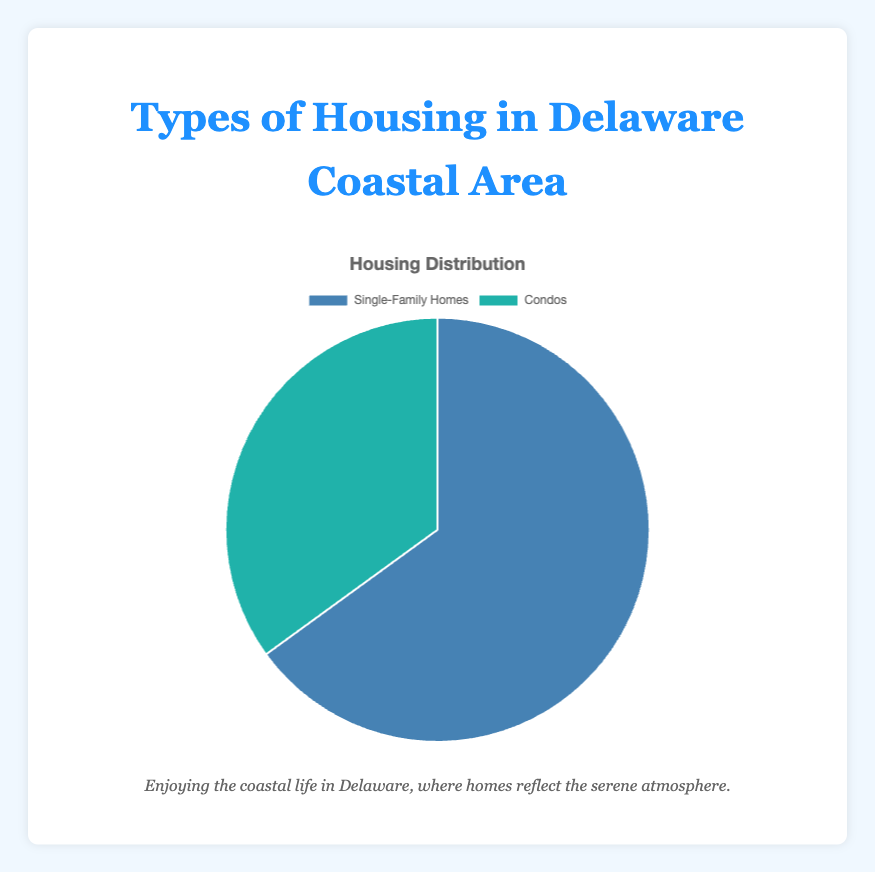What percentage of housing comprises single-family homes in the Delaware coastal area? The pie chart visually and textually indicates that 65% of the housing in the Delaware coastal area are single-family homes.
Answer: 65% What is the percentage of condos in the Delaware coastal area? From the pie chart, it is clearly labeled that 35% of the housing types are condos.
Answer: 35% How much greater is the percentage of single-family homes compared to condos? The percentage of single-family homes is 65% and condos are 35%. The difference is 65% - 35%, which is 30%.
Answer: 30% What fraction of the housing types are single-family homes? To find the fraction, use the percentage for single-family homes which is 65%. Convert the percentage to a fraction, 65% is equivalent to 65/100 or simplified to 13/20.
Answer: 13/20 Which type of housing is more prevalent in the Delaware coastal area, and by how much? Single-family homes are more prevalent at 65% compared to condos at 35%. The difference is 65% - 35%, resulting in a 30% higher prevalence of single-family homes.
Answer: Single-family homes by 30% If 1000 new housing units are built, how many of them are likely to be condos? Based on the pie chart, 35% of the housing units are condos. Thus, 35% of 1000 units are likely to be 0.35 * 1000 = 350 units.
Answer: 350 units What is the combined percentage of both housing types? Simply add the percentage of single-family homes (65%) and condos (35%) which equals 65% + 35% = 100%.
Answer: 100% What is the ratio of single-family homes to condos in the Delaware coastal area? The percentage of single-family homes is 65% while that of condos is 35%. The ratio is obtained by dividing 65% by 35%, which gives 65 / 35 = 13 / 7 when simplified.
Answer: 13:7 If there were 200 single-family homes, how many condos would there be? Given that single-family homes represent 65% and condos 35%, we can set up a proportion to find the number of condos. Thus, (Condos / 200) = 35 / 65. Solving for Condos, we get Condos = (200 * 35) / 65 = 107.69 ≈ 108.
Answer: Approximately 108 condos How does the color of the segments help in distinguishing between the two types of housing? The chart uses different colors to represent each housing type: Single-family homes are depicted with a blueish color and condos with a teal color, which visually distinguishes the two segments clearly.
Answer: Different colors (blueish and teal) 